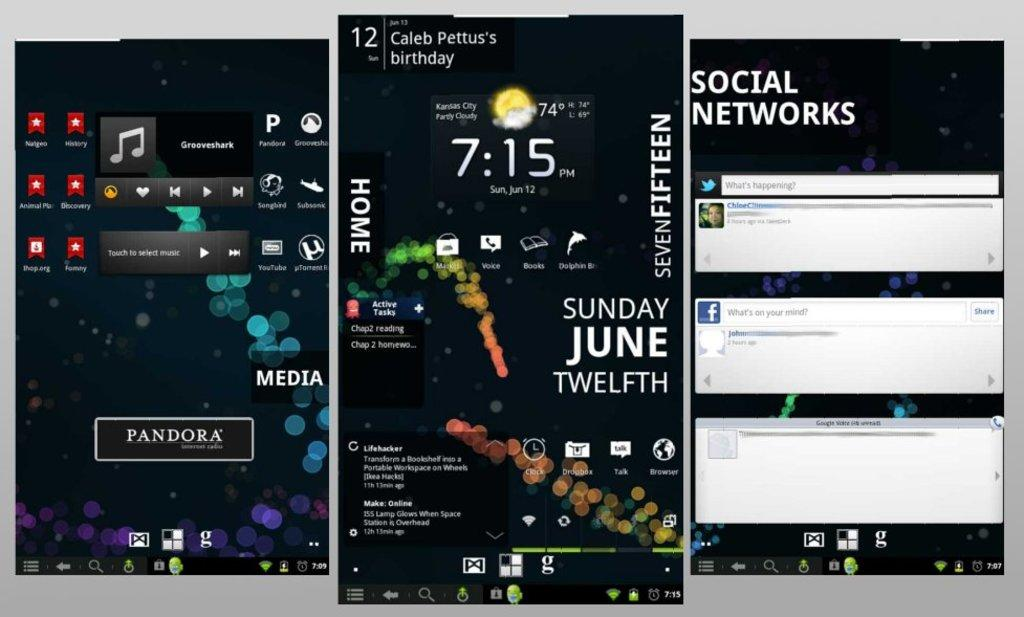<image>
Share a concise interpretation of the image provided. Collage of screens including one that shows the time at 7:15PM. 